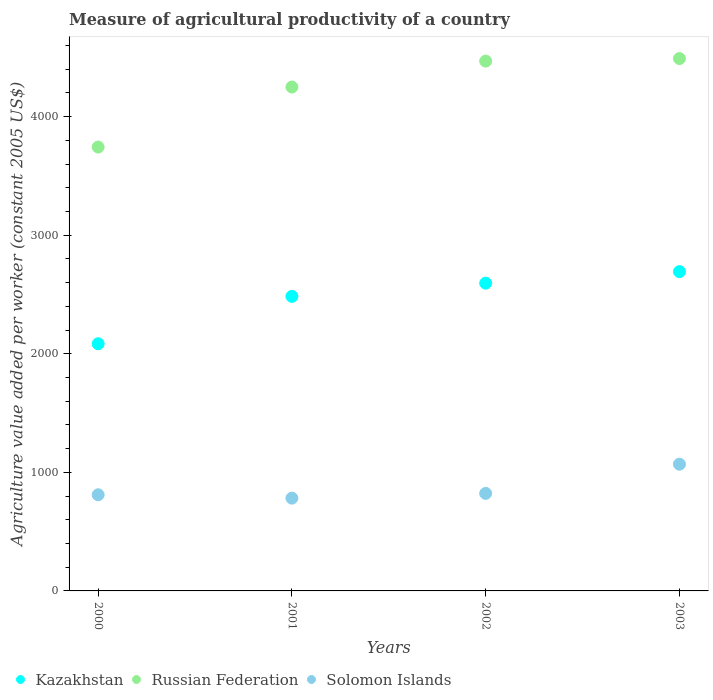How many different coloured dotlines are there?
Offer a very short reply. 3. What is the measure of agricultural productivity in Solomon Islands in 2002?
Offer a terse response. 822.41. Across all years, what is the maximum measure of agricultural productivity in Solomon Islands?
Provide a short and direct response. 1068.71. Across all years, what is the minimum measure of agricultural productivity in Kazakhstan?
Provide a short and direct response. 2084.38. In which year was the measure of agricultural productivity in Russian Federation minimum?
Your response must be concise. 2000. What is the total measure of agricultural productivity in Kazakhstan in the graph?
Provide a short and direct response. 9856.55. What is the difference between the measure of agricultural productivity in Kazakhstan in 2001 and that in 2002?
Give a very brief answer. -111.48. What is the difference between the measure of agricultural productivity in Kazakhstan in 2002 and the measure of agricultural productivity in Solomon Islands in 2001?
Your response must be concise. 1813.07. What is the average measure of agricultural productivity in Kazakhstan per year?
Provide a succinct answer. 2464.14. In the year 2002, what is the difference between the measure of agricultural productivity in Solomon Islands and measure of agricultural productivity in Kazakhstan?
Give a very brief answer. -1773.14. In how many years, is the measure of agricultural productivity in Russian Federation greater than 2600 US$?
Your response must be concise. 4. What is the ratio of the measure of agricultural productivity in Russian Federation in 2000 to that in 2003?
Provide a succinct answer. 0.83. Is the measure of agricultural productivity in Kazakhstan in 2002 less than that in 2003?
Your answer should be compact. Yes. Is the difference between the measure of agricultural productivity in Solomon Islands in 2001 and 2002 greater than the difference between the measure of agricultural productivity in Kazakhstan in 2001 and 2002?
Ensure brevity in your answer.  Yes. What is the difference between the highest and the second highest measure of agricultural productivity in Russian Federation?
Offer a terse response. 21.45. What is the difference between the highest and the lowest measure of agricultural productivity in Russian Federation?
Your response must be concise. 746.32. In how many years, is the measure of agricultural productivity in Kazakhstan greater than the average measure of agricultural productivity in Kazakhstan taken over all years?
Your answer should be compact. 3. Is it the case that in every year, the sum of the measure of agricultural productivity in Kazakhstan and measure of agricultural productivity in Solomon Islands  is greater than the measure of agricultural productivity in Russian Federation?
Make the answer very short. No. How many dotlines are there?
Offer a terse response. 3. What is the difference between two consecutive major ticks on the Y-axis?
Provide a succinct answer. 1000. Does the graph contain any zero values?
Give a very brief answer. No. Does the graph contain grids?
Offer a terse response. No. Where does the legend appear in the graph?
Your response must be concise. Bottom left. How many legend labels are there?
Ensure brevity in your answer.  3. What is the title of the graph?
Provide a short and direct response. Measure of agricultural productivity of a country. Does "Panama" appear as one of the legend labels in the graph?
Give a very brief answer. No. What is the label or title of the Y-axis?
Provide a short and direct response. Agriculture value added per worker (constant 2005 US$). What is the Agriculture value added per worker (constant 2005 US$) of Kazakhstan in 2000?
Your response must be concise. 2084.38. What is the Agriculture value added per worker (constant 2005 US$) in Russian Federation in 2000?
Your answer should be compact. 3743.25. What is the Agriculture value added per worker (constant 2005 US$) in Solomon Islands in 2000?
Make the answer very short. 810.78. What is the Agriculture value added per worker (constant 2005 US$) in Kazakhstan in 2001?
Provide a short and direct response. 2484.06. What is the Agriculture value added per worker (constant 2005 US$) in Russian Federation in 2001?
Your answer should be very brief. 4249.41. What is the Agriculture value added per worker (constant 2005 US$) of Solomon Islands in 2001?
Give a very brief answer. 782.48. What is the Agriculture value added per worker (constant 2005 US$) of Kazakhstan in 2002?
Your response must be concise. 2595.55. What is the Agriculture value added per worker (constant 2005 US$) in Russian Federation in 2002?
Your answer should be very brief. 4468.13. What is the Agriculture value added per worker (constant 2005 US$) in Solomon Islands in 2002?
Your response must be concise. 822.41. What is the Agriculture value added per worker (constant 2005 US$) in Kazakhstan in 2003?
Offer a terse response. 2692.56. What is the Agriculture value added per worker (constant 2005 US$) of Russian Federation in 2003?
Offer a very short reply. 4489.58. What is the Agriculture value added per worker (constant 2005 US$) of Solomon Islands in 2003?
Offer a very short reply. 1068.71. Across all years, what is the maximum Agriculture value added per worker (constant 2005 US$) in Kazakhstan?
Your answer should be compact. 2692.56. Across all years, what is the maximum Agriculture value added per worker (constant 2005 US$) in Russian Federation?
Make the answer very short. 4489.58. Across all years, what is the maximum Agriculture value added per worker (constant 2005 US$) in Solomon Islands?
Offer a very short reply. 1068.71. Across all years, what is the minimum Agriculture value added per worker (constant 2005 US$) in Kazakhstan?
Your answer should be compact. 2084.38. Across all years, what is the minimum Agriculture value added per worker (constant 2005 US$) of Russian Federation?
Your answer should be compact. 3743.25. Across all years, what is the minimum Agriculture value added per worker (constant 2005 US$) of Solomon Islands?
Offer a terse response. 782.48. What is the total Agriculture value added per worker (constant 2005 US$) of Kazakhstan in the graph?
Your answer should be compact. 9856.55. What is the total Agriculture value added per worker (constant 2005 US$) of Russian Federation in the graph?
Provide a succinct answer. 1.70e+04. What is the total Agriculture value added per worker (constant 2005 US$) in Solomon Islands in the graph?
Offer a very short reply. 3484.38. What is the difference between the Agriculture value added per worker (constant 2005 US$) of Kazakhstan in 2000 and that in 2001?
Your answer should be compact. -399.68. What is the difference between the Agriculture value added per worker (constant 2005 US$) of Russian Federation in 2000 and that in 2001?
Offer a very short reply. -506.16. What is the difference between the Agriculture value added per worker (constant 2005 US$) of Solomon Islands in 2000 and that in 2001?
Make the answer very short. 28.3. What is the difference between the Agriculture value added per worker (constant 2005 US$) in Kazakhstan in 2000 and that in 2002?
Your answer should be very brief. -511.16. What is the difference between the Agriculture value added per worker (constant 2005 US$) in Russian Federation in 2000 and that in 2002?
Keep it short and to the point. -724.88. What is the difference between the Agriculture value added per worker (constant 2005 US$) in Solomon Islands in 2000 and that in 2002?
Keep it short and to the point. -11.63. What is the difference between the Agriculture value added per worker (constant 2005 US$) of Kazakhstan in 2000 and that in 2003?
Provide a short and direct response. -608.17. What is the difference between the Agriculture value added per worker (constant 2005 US$) of Russian Federation in 2000 and that in 2003?
Your answer should be compact. -746.32. What is the difference between the Agriculture value added per worker (constant 2005 US$) of Solomon Islands in 2000 and that in 2003?
Provide a short and direct response. -257.93. What is the difference between the Agriculture value added per worker (constant 2005 US$) of Kazakhstan in 2001 and that in 2002?
Keep it short and to the point. -111.48. What is the difference between the Agriculture value added per worker (constant 2005 US$) in Russian Federation in 2001 and that in 2002?
Make the answer very short. -218.72. What is the difference between the Agriculture value added per worker (constant 2005 US$) in Solomon Islands in 2001 and that in 2002?
Make the answer very short. -39.93. What is the difference between the Agriculture value added per worker (constant 2005 US$) in Kazakhstan in 2001 and that in 2003?
Provide a succinct answer. -208.49. What is the difference between the Agriculture value added per worker (constant 2005 US$) of Russian Federation in 2001 and that in 2003?
Ensure brevity in your answer.  -240.16. What is the difference between the Agriculture value added per worker (constant 2005 US$) in Solomon Islands in 2001 and that in 2003?
Give a very brief answer. -286.23. What is the difference between the Agriculture value added per worker (constant 2005 US$) of Kazakhstan in 2002 and that in 2003?
Keep it short and to the point. -97.01. What is the difference between the Agriculture value added per worker (constant 2005 US$) in Russian Federation in 2002 and that in 2003?
Your answer should be very brief. -21.45. What is the difference between the Agriculture value added per worker (constant 2005 US$) in Solomon Islands in 2002 and that in 2003?
Make the answer very short. -246.3. What is the difference between the Agriculture value added per worker (constant 2005 US$) in Kazakhstan in 2000 and the Agriculture value added per worker (constant 2005 US$) in Russian Federation in 2001?
Provide a succinct answer. -2165.03. What is the difference between the Agriculture value added per worker (constant 2005 US$) of Kazakhstan in 2000 and the Agriculture value added per worker (constant 2005 US$) of Solomon Islands in 2001?
Offer a very short reply. 1301.9. What is the difference between the Agriculture value added per worker (constant 2005 US$) of Russian Federation in 2000 and the Agriculture value added per worker (constant 2005 US$) of Solomon Islands in 2001?
Your answer should be very brief. 2960.77. What is the difference between the Agriculture value added per worker (constant 2005 US$) of Kazakhstan in 2000 and the Agriculture value added per worker (constant 2005 US$) of Russian Federation in 2002?
Provide a succinct answer. -2383.75. What is the difference between the Agriculture value added per worker (constant 2005 US$) of Kazakhstan in 2000 and the Agriculture value added per worker (constant 2005 US$) of Solomon Islands in 2002?
Keep it short and to the point. 1261.97. What is the difference between the Agriculture value added per worker (constant 2005 US$) of Russian Federation in 2000 and the Agriculture value added per worker (constant 2005 US$) of Solomon Islands in 2002?
Provide a succinct answer. 2920.84. What is the difference between the Agriculture value added per worker (constant 2005 US$) in Kazakhstan in 2000 and the Agriculture value added per worker (constant 2005 US$) in Russian Federation in 2003?
Your answer should be very brief. -2405.19. What is the difference between the Agriculture value added per worker (constant 2005 US$) in Kazakhstan in 2000 and the Agriculture value added per worker (constant 2005 US$) in Solomon Islands in 2003?
Give a very brief answer. 1015.67. What is the difference between the Agriculture value added per worker (constant 2005 US$) of Russian Federation in 2000 and the Agriculture value added per worker (constant 2005 US$) of Solomon Islands in 2003?
Provide a short and direct response. 2674.54. What is the difference between the Agriculture value added per worker (constant 2005 US$) of Kazakhstan in 2001 and the Agriculture value added per worker (constant 2005 US$) of Russian Federation in 2002?
Keep it short and to the point. -1984.07. What is the difference between the Agriculture value added per worker (constant 2005 US$) in Kazakhstan in 2001 and the Agriculture value added per worker (constant 2005 US$) in Solomon Islands in 2002?
Give a very brief answer. 1661.65. What is the difference between the Agriculture value added per worker (constant 2005 US$) in Russian Federation in 2001 and the Agriculture value added per worker (constant 2005 US$) in Solomon Islands in 2002?
Give a very brief answer. 3427. What is the difference between the Agriculture value added per worker (constant 2005 US$) of Kazakhstan in 2001 and the Agriculture value added per worker (constant 2005 US$) of Russian Federation in 2003?
Offer a terse response. -2005.51. What is the difference between the Agriculture value added per worker (constant 2005 US$) in Kazakhstan in 2001 and the Agriculture value added per worker (constant 2005 US$) in Solomon Islands in 2003?
Offer a very short reply. 1415.35. What is the difference between the Agriculture value added per worker (constant 2005 US$) of Russian Federation in 2001 and the Agriculture value added per worker (constant 2005 US$) of Solomon Islands in 2003?
Offer a very short reply. 3180.7. What is the difference between the Agriculture value added per worker (constant 2005 US$) in Kazakhstan in 2002 and the Agriculture value added per worker (constant 2005 US$) in Russian Federation in 2003?
Give a very brief answer. -1894.03. What is the difference between the Agriculture value added per worker (constant 2005 US$) in Kazakhstan in 2002 and the Agriculture value added per worker (constant 2005 US$) in Solomon Islands in 2003?
Your answer should be very brief. 1526.84. What is the difference between the Agriculture value added per worker (constant 2005 US$) of Russian Federation in 2002 and the Agriculture value added per worker (constant 2005 US$) of Solomon Islands in 2003?
Keep it short and to the point. 3399.42. What is the average Agriculture value added per worker (constant 2005 US$) in Kazakhstan per year?
Your response must be concise. 2464.14. What is the average Agriculture value added per worker (constant 2005 US$) of Russian Federation per year?
Provide a succinct answer. 4237.59. What is the average Agriculture value added per worker (constant 2005 US$) in Solomon Islands per year?
Your response must be concise. 871.1. In the year 2000, what is the difference between the Agriculture value added per worker (constant 2005 US$) in Kazakhstan and Agriculture value added per worker (constant 2005 US$) in Russian Federation?
Provide a short and direct response. -1658.87. In the year 2000, what is the difference between the Agriculture value added per worker (constant 2005 US$) of Kazakhstan and Agriculture value added per worker (constant 2005 US$) of Solomon Islands?
Give a very brief answer. 1273.61. In the year 2000, what is the difference between the Agriculture value added per worker (constant 2005 US$) of Russian Federation and Agriculture value added per worker (constant 2005 US$) of Solomon Islands?
Offer a very short reply. 2932.47. In the year 2001, what is the difference between the Agriculture value added per worker (constant 2005 US$) of Kazakhstan and Agriculture value added per worker (constant 2005 US$) of Russian Federation?
Offer a terse response. -1765.35. In the year 2001, what is the difference between the Agriculture value added per worker (constant 2005 US$) in Kazakhstan and Agriculture value added per worker (constant 2005 US$) in Solomon Islands?
Make the answer very short. 1701.58. In the year 2001, what is the difference between the Agriculture value added per worker (constant 2005 US$) in Russian Federation and Agriculture value added per worker (constant 2005 US$) in Solomon Islands?
Make the answer very short. 3466.93. In the year 2002, what is the difference between the Agriculture value added per worker (constant 2005 US$) of Kazakhstan and Agriculture value added per worker (constant 2005 US$) of Russian Federation?
Make the answer very short. -1872.58. In the year 2002, what is the difference between the Agriculture value added per worker (constant 2005 US$) of Kazakhstan and Agriculture value added per worker (constant 2005 US$) of Solomon Islands?
Give a very brief answer. 1773.14. In the year 2002, what is the difference between the Agriculture value added per worker (constant 2005 US$) of Russian Federation and Agriculture value added per worker (constant 2005 US$) of Solomon Islands?
Provide a succinct answer. 3645.72. In the year 2003, what is the difference between the Agriculture value added per worker (constant 2005 US$) in Kazakhstan and Agriculture value added per worker (constant 2005 US$) in Russian Federation?
Give a very brief answer. -1797.02. In the year 2003, what is the difference between the Agriculture value added per worker (constant 2005 US$) of Kazakhstan and Agriculture value added per worker (constant 2005 US$) of Solomon Islands?
Give a very brief answer. 1623.84. In the year 2003, what is the difference between the Agriculture value added per worker (constant 2005 US$) in Russian Federation and Agriculture value added per worker (constant 2005 US$) in Solomon Islands?
Your answer should be very brief. 3420.86. What is the ratio of the Agriculture value added per worker (constant 2005 US$) of Kazakhstan in 2000 to that in 2001?
Your answer should be very brief. 0.84. What is the ratio of the Agriculture value added per worker (constant 2005 US$) of Russian Federation in 2000 to that in 2001?
Offer a very short reply. 0.88. What is the ratio of the Agriculture value added per worker (constant 2005 US$) in Solomon Islands in 2000 to that in 2001?
Give a very brief answer. 1.04. What is the ratio of the Agriculture value added per worker (constant 2005 US$) in Kazakhstan in 2000 to that in 2002?
Provide a succinct answer. 0.8. What is the ratio of the Agriculture value added per worker (constant 2005 US$) in Russian Federation in 2000 to that in 2002?
Your answer should be very brief. 0.84. What is the ratio of the Agriculture value added per worker (constant 2005 US$) in Solomon Islands in 2000 to that in 2002?
Provide a short and direct response. 0.99. What is the ratio of the Agriculture value added per worker (constant 2005 US$) in Kazakhstan in 2000 to that in 2003?
Provide a short and direct response. 0.77. What is the ratio of the Agriculture value added per worker (constant 2005 US$) of Russian Federation in 2000 to that in 2003?
Your answer should be very brief. 0.83. What is the ratio of the Agriculture value added per worker (constant 2005 US$) of Solomon Islands in 2000 to that in 2003?
Provide a short and direct response. 0.76. What is the ratio of the Agriculture value added per worker (constant 2005 US$) in Russian Federation in 2001 to that in 2002?
Provide a succinct answer. 0.95. What is the ratio of the Agriculture value added per worker (constant 2005 US$) of Solomon Islands in 2001 to that in 2002?
Your answer should be very brief. 0.95. What is the ratio of the Agriculture value added per worker (constant 2005 US$) of Kazakhstan in 2001 to that in 2003?
Give a very brief answer. 0.92. What is the ratio of the Agriculture value added per worker (constant 2005 US$) of Russian Federation in 2001 to that in 2003?
Offer a terse response. 0.95. What is the ratio of the Agriculture value added per worker (constant 2005 US$) in Solomon Islands in 2001 to that in 2003?
Ensure brevity in your answer.  0.73. What is the ratio of the Agriculture value added per worker (constant 2005 US$) of Russian Federation in 2002 to that in 2003?
Your answer should be compact. 1. What is the ratio of the Agriculture value added per worker (constant 2005 US$) of Solomon Islands in 2002 to that in 2003?
Make the answer very short. 0.77. What is the difference between the highest and the second highest Agriculture value added per worker (constant 2005 US$) in Kazakhstan?
Provide a succinct answer. 97.01. What is the difference between the highest and the second highest Agriculture value added per worker (constant 2005 US$) of Russian Federation?
Your answer should be very brief. 21.45. What is the difference between the highest and the second highest Agriculture value added per worker (constant 2005 US$) of Solomon Islands?
Offer a very short reply. 246.3. What is the difference between the highest and the lowest Agriculture value added per worker (constant 2005 US$) in Kazakhstan?
Provide a succinct answer. 608.17. What is the difference between the highest and the lowest Agriculture value added per worker (constant 2005 US$) of Russian Federation?
Your answer should be very brief. 746.32. What is the difference between the highest and the lowest Agriculture value added per worker (constant 2005 US$) of Solomon Islands?
Your answer should be very brief. 286.23. 